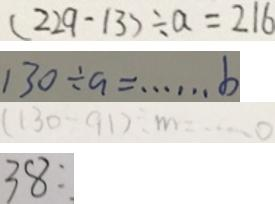<formula> <loc_0><loc_0><loc_500><loc_500>( 2 2 9 - 1 3 ) \div a = 2 1 6 
 1 3 0 \div a = \cdots b 
 ( 1 3 0 - 9 1 ) \div m = \cdots o 
 3 8 : .</formula> 